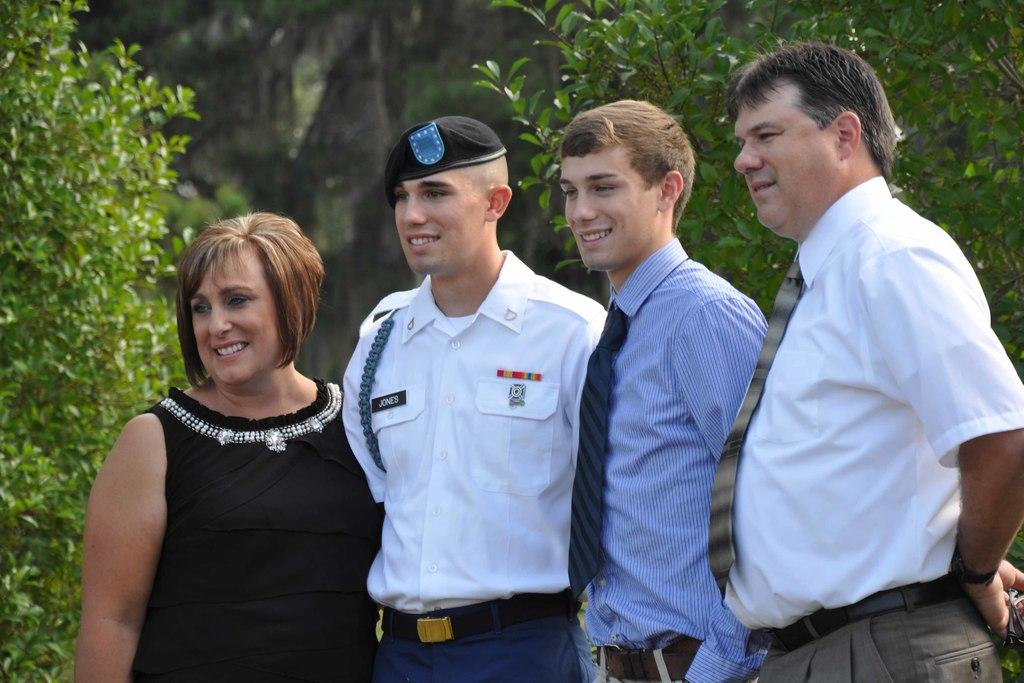How many people are present in the image? There are four persons standing in the image. Can you describe the clothing of one of the persons? One person is wearing a white and blue color dress. What can be seen in the background of the image? There are trees visible in the background of the image. What is the color of the trees in the image? The trees are green in color. What type of authority figure can be seen in the image? There is no authority figure present in the image. How many rows of corn are visible in the image? There is no corn present in the image. 